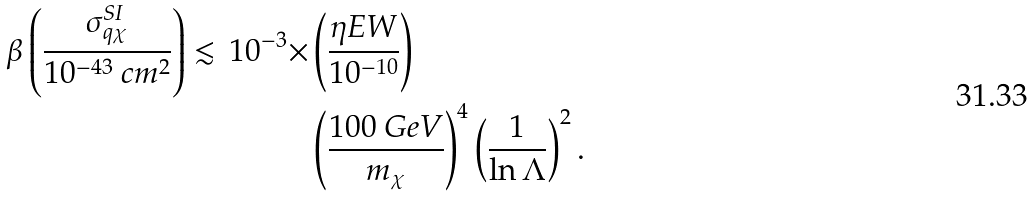Convert formula to latex. <formula><loc_0><loc_0><loc_500><loc_500>\beta \left ( \frac { \sigma ^ { S I } _ { q \chi } } { 1 0 ^ { - 4 3 } \ c m ^ { 2 } } \right ) \lesssim \, 1 0 ^ { - 3 } \times & \left ( \frac { \eta E W } { 1 0 ^ { - 1 0 } } \right ) \\ & \left ( \frac { 1 0 0 \ G e V } { m _ { \chi } } \right ) ^ { 4 } \left ( \frac { 1 } { \ln \Lambda } \right ) ^ { 2 } .</formula> 